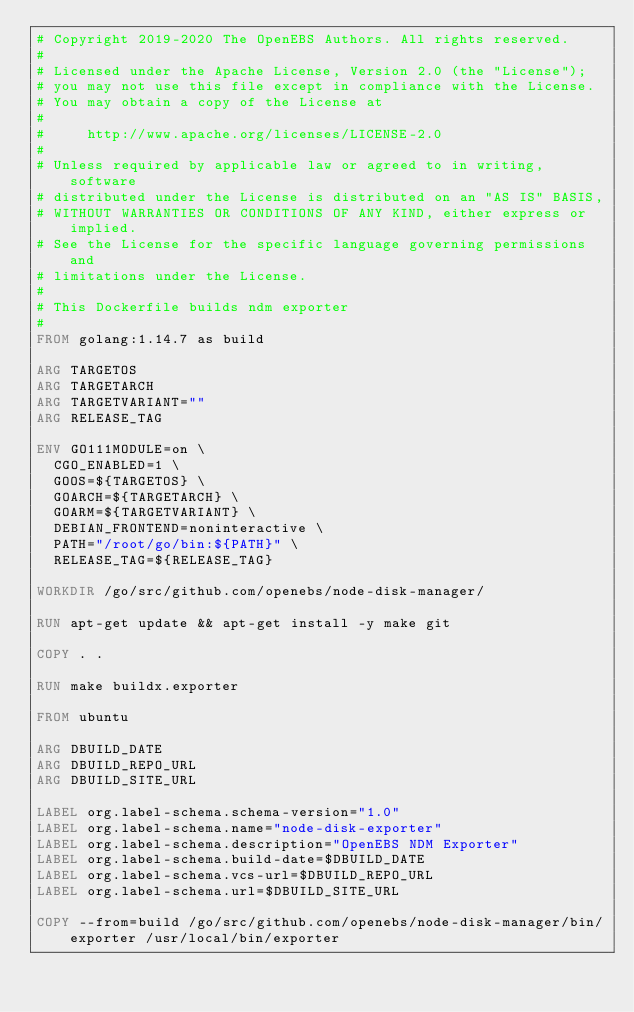<code> <loc_0><loc_0><loc_500><loc_500><_Dockerfile_># Copyright 2019-2020 The OpenEBS Authors. All rights reserved.
#
# Licensed under the Apache License, Version 2.0 (the "License");
# you may not use this file except in compliance with the License.
# You may obtain a copy of the License at
#
#     http://www.apache.org/licenses/LICENSE-2.0
#
# Unless required by applicable law or agreed to in writing, software
# distributed under the License is distributed on an "AS IS" BASIS,
# WITHOUT WARRANTIES OR CONDITIONS OF ANY KIND, either express or implied.
# See the License for the specific language governing permissions and
# limitations under the License.
#
# This Dockerfile builds ndm exporter
#
FROM golang:1.14.7 as build

ARG TARGETOS
ARG TARGETARCH
ARG TARGETVARIANT=""
ARG RELEASE_TAG

ENV GO111MODULE=on \
  CGO_ENABLED=1 \
  GOOS=${TARGETOS} \
  GOARCH=${TARGETARCH} \
  GOARM=${TARGETVARIANT} \
  DEBIAN_FRONTEND=noninteractive \
  PATH="/root/go/bin:${PATH}" \
  RELEASE_TAG=${RELEASE_TAG}

WORKDIR /go/src/github.com/openebs/node-disk-manager/

RUN apt-get update && apt-get install -y make git

COPY . .

RUN make buildx.exporter

FROM ubuntu

ARG DBUILD_DATE
ARG DBUILD_REPO_URL
ARG DBUILD_SITE_URL

LABEL org.label-schema.schema-version="1.0"
LABEL org.label-schema.name="node-disk-exporter"
LABEL org.label-schema.description="OpenEBS NDM Exporter"
LABEL org.label-schema.build-date=$DBUILD_DATE
LABEL org.label-schema.vcs-url=$DBUILD_REPO_URL
LABEL org.label-schema.url=$DBUILD_SITE_URL

COPY --from=build /go/src/github.com/openebs/node-disk-manager/bin/exporter /usr/local/bin/exporter
</code> 